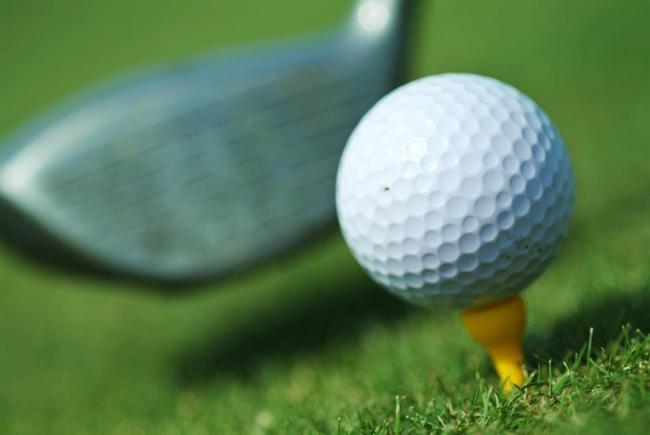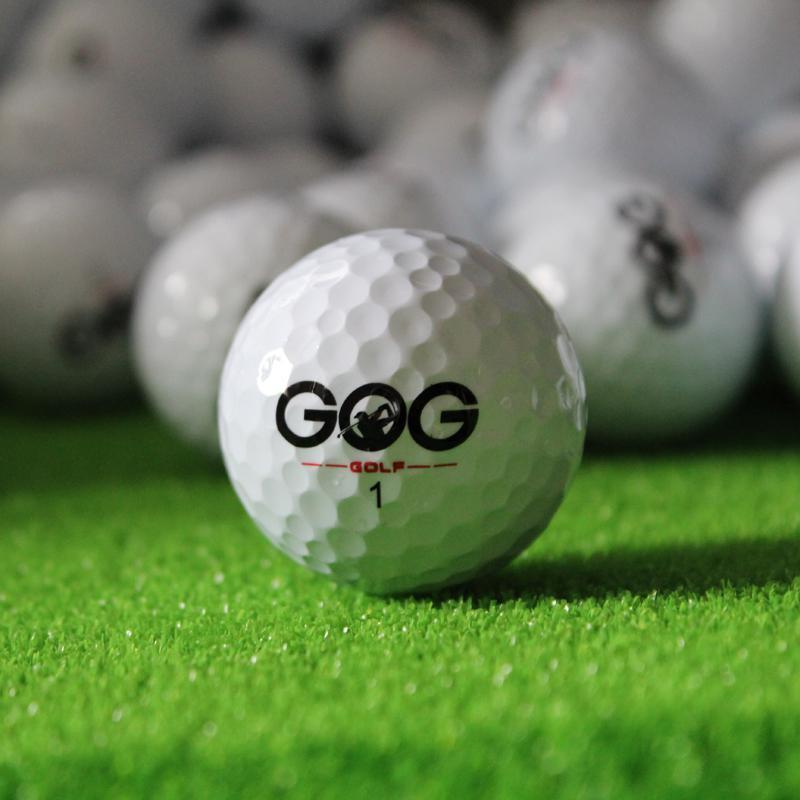The first image is the image on the left, the second image is the image on the right. Assess this claim about the two images: "A golf club is behind at least one golf ball.". Correct or not? Answer yes or no. Yes. The first image is the image on the left, the second image is the image on the right. For the images shown, is this caption "At least one image shows a golf ball on top of a tee." true? Answer yes or no. Yes. 